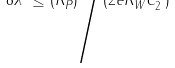Convert formula to latex. <formula><loc_0><loc_0><loc_500><loc_500>8 \lambda ^ { 2 } \leq ( R _ { P } ^ { 2 } ) \Big / ( 2 e R _ { W } ^ { 2 } C ^ { \phi } _ { 2 } )</formula> 